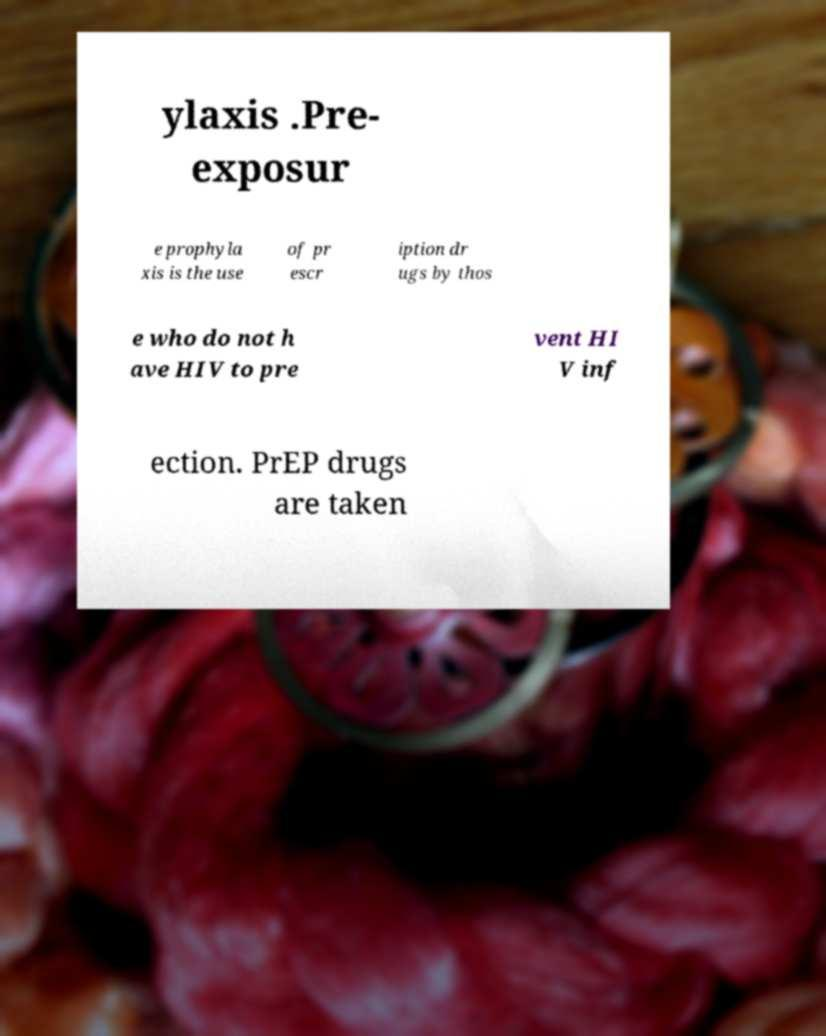Can you read and provide the text displayed in the image?This photo seems to have some interesting text. Can you extract and type it out for me? ylaxis .Pre- exposur e prophyla xis is the use of pr escr iption dr ugs by thos e who do not h ave HIV to pre vent HI V inf ection. PrEP drugs are taken 